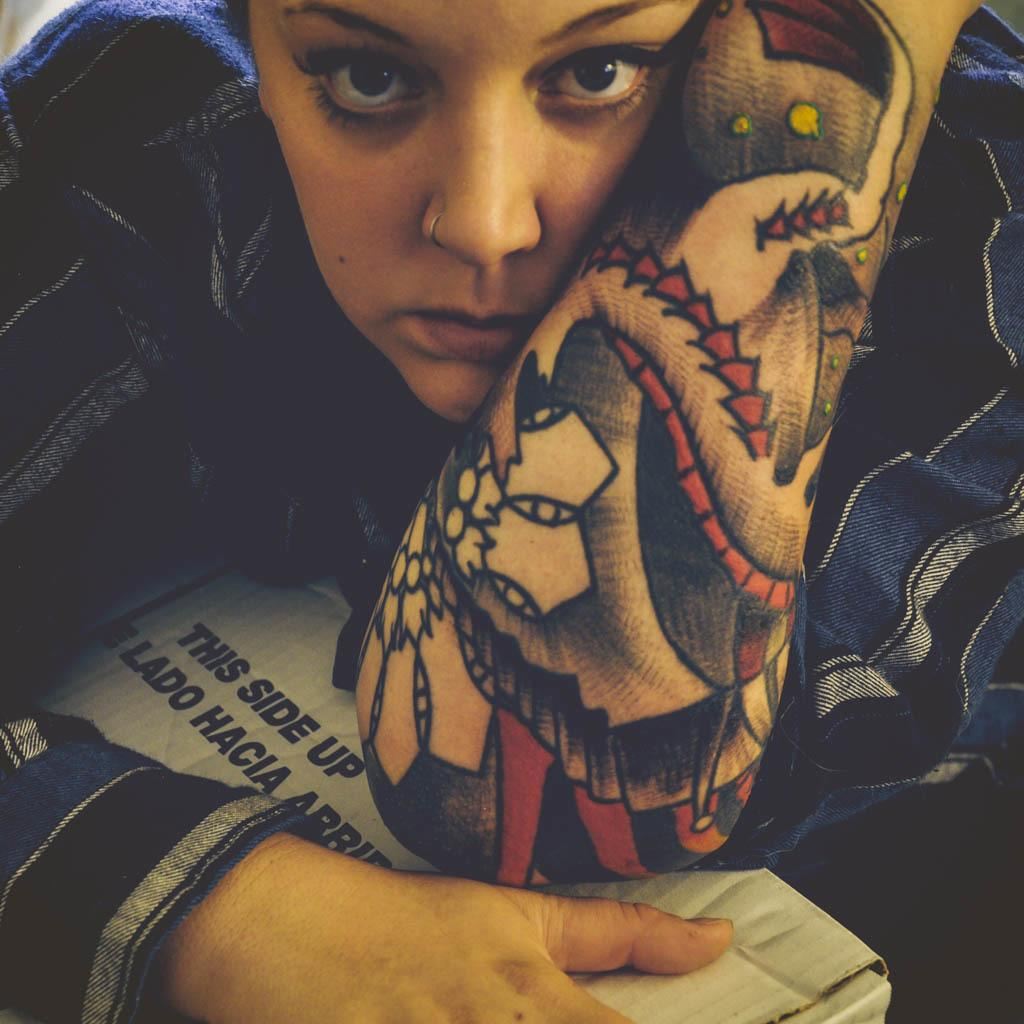Who is the main subject in the image? There is a woman in the center of the image. What is the woman holding in the image? The woman is holding a box. Can you describe the box in the image? There is text on the box. What type of appliance is the woman angry about in the image? There is no appliance or indication of anger present in the image. 